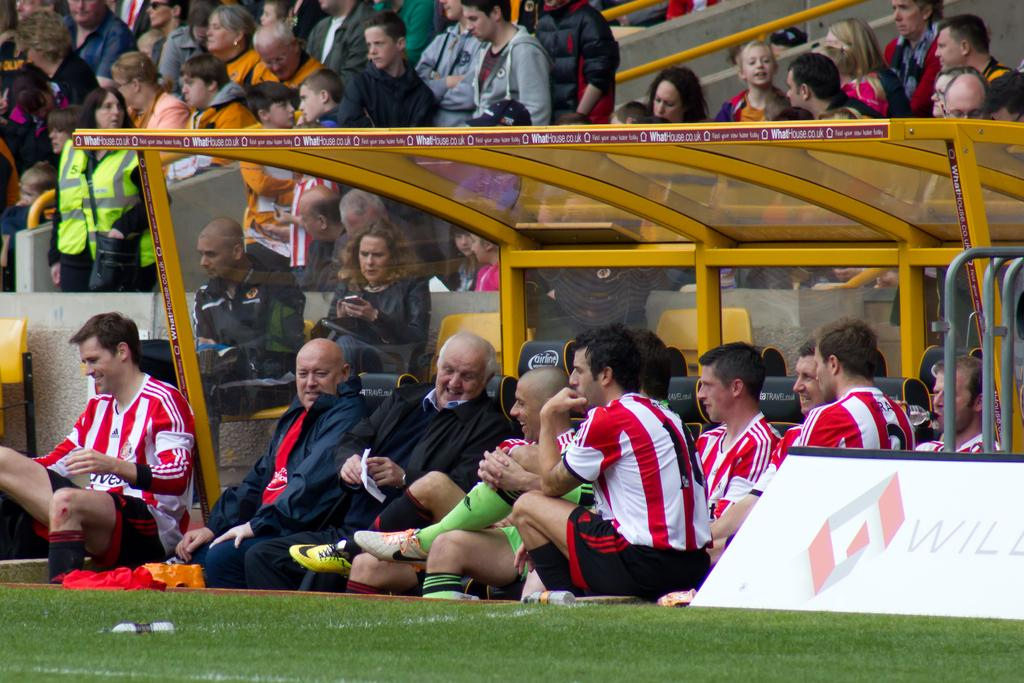What are the people in the image doing? There is a group of people sitting on the ground in the image. What structure can be seen in the image? There is a yellow shelter in the image. Are there any people standing in the image? Yes, there are people standing at the back in the image. Are there any chairs in the image? Yes, some people are sitting on chairs in the image. What is the name of the horse in the image? There is no horse present in the image. How many slaves are visible in the image? The concept of slavery is not relevant to the image, as it does not depict any such situation. 